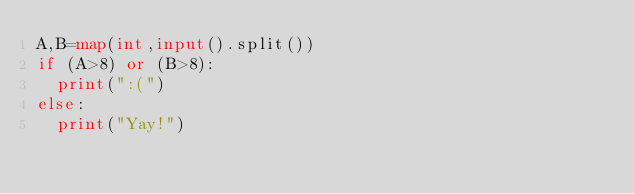<code> <loc_0><loc_0><loc_500><loc_500><_Python_>A,B=map(int,input().split())
if (A>8) or (B>8):
  print(":(")
else:
  print("Yay!")</code> 